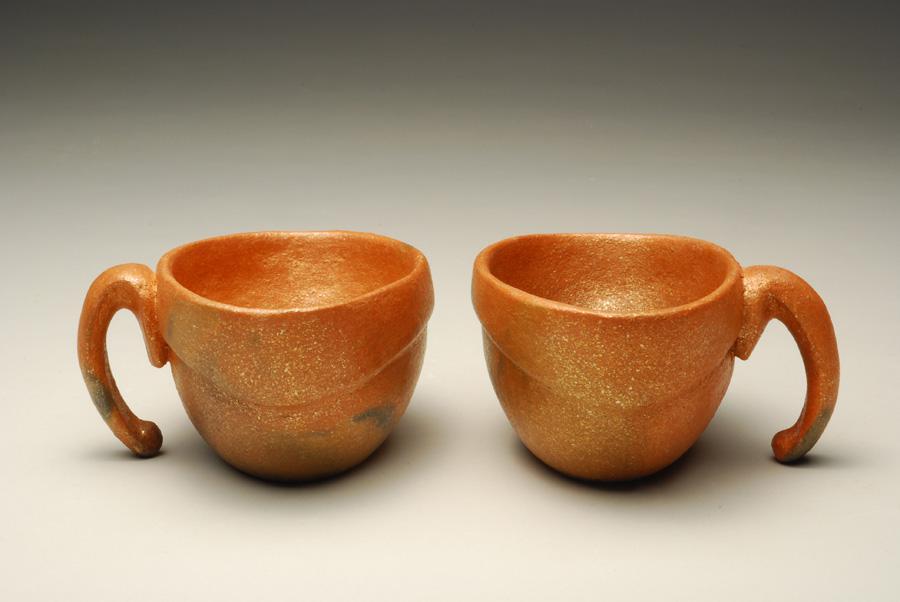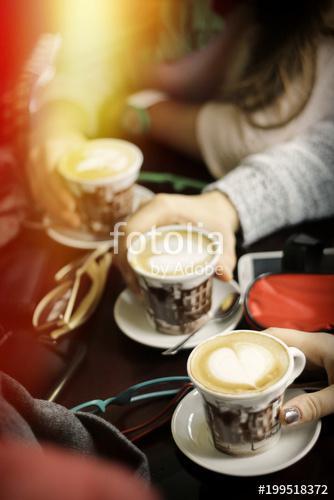The first image is the image on the left, the second image is the image on the right. For the images displayed, is the sentence "In at least one image there is a total of four cups." factually correct? Answer yes or no. No. The first image is the image on the left, the second image is the image on the right. Analyze the images presented: Is the assertion "There are fewer than ten cups in total." valid? Answer yes or no. Yes. 